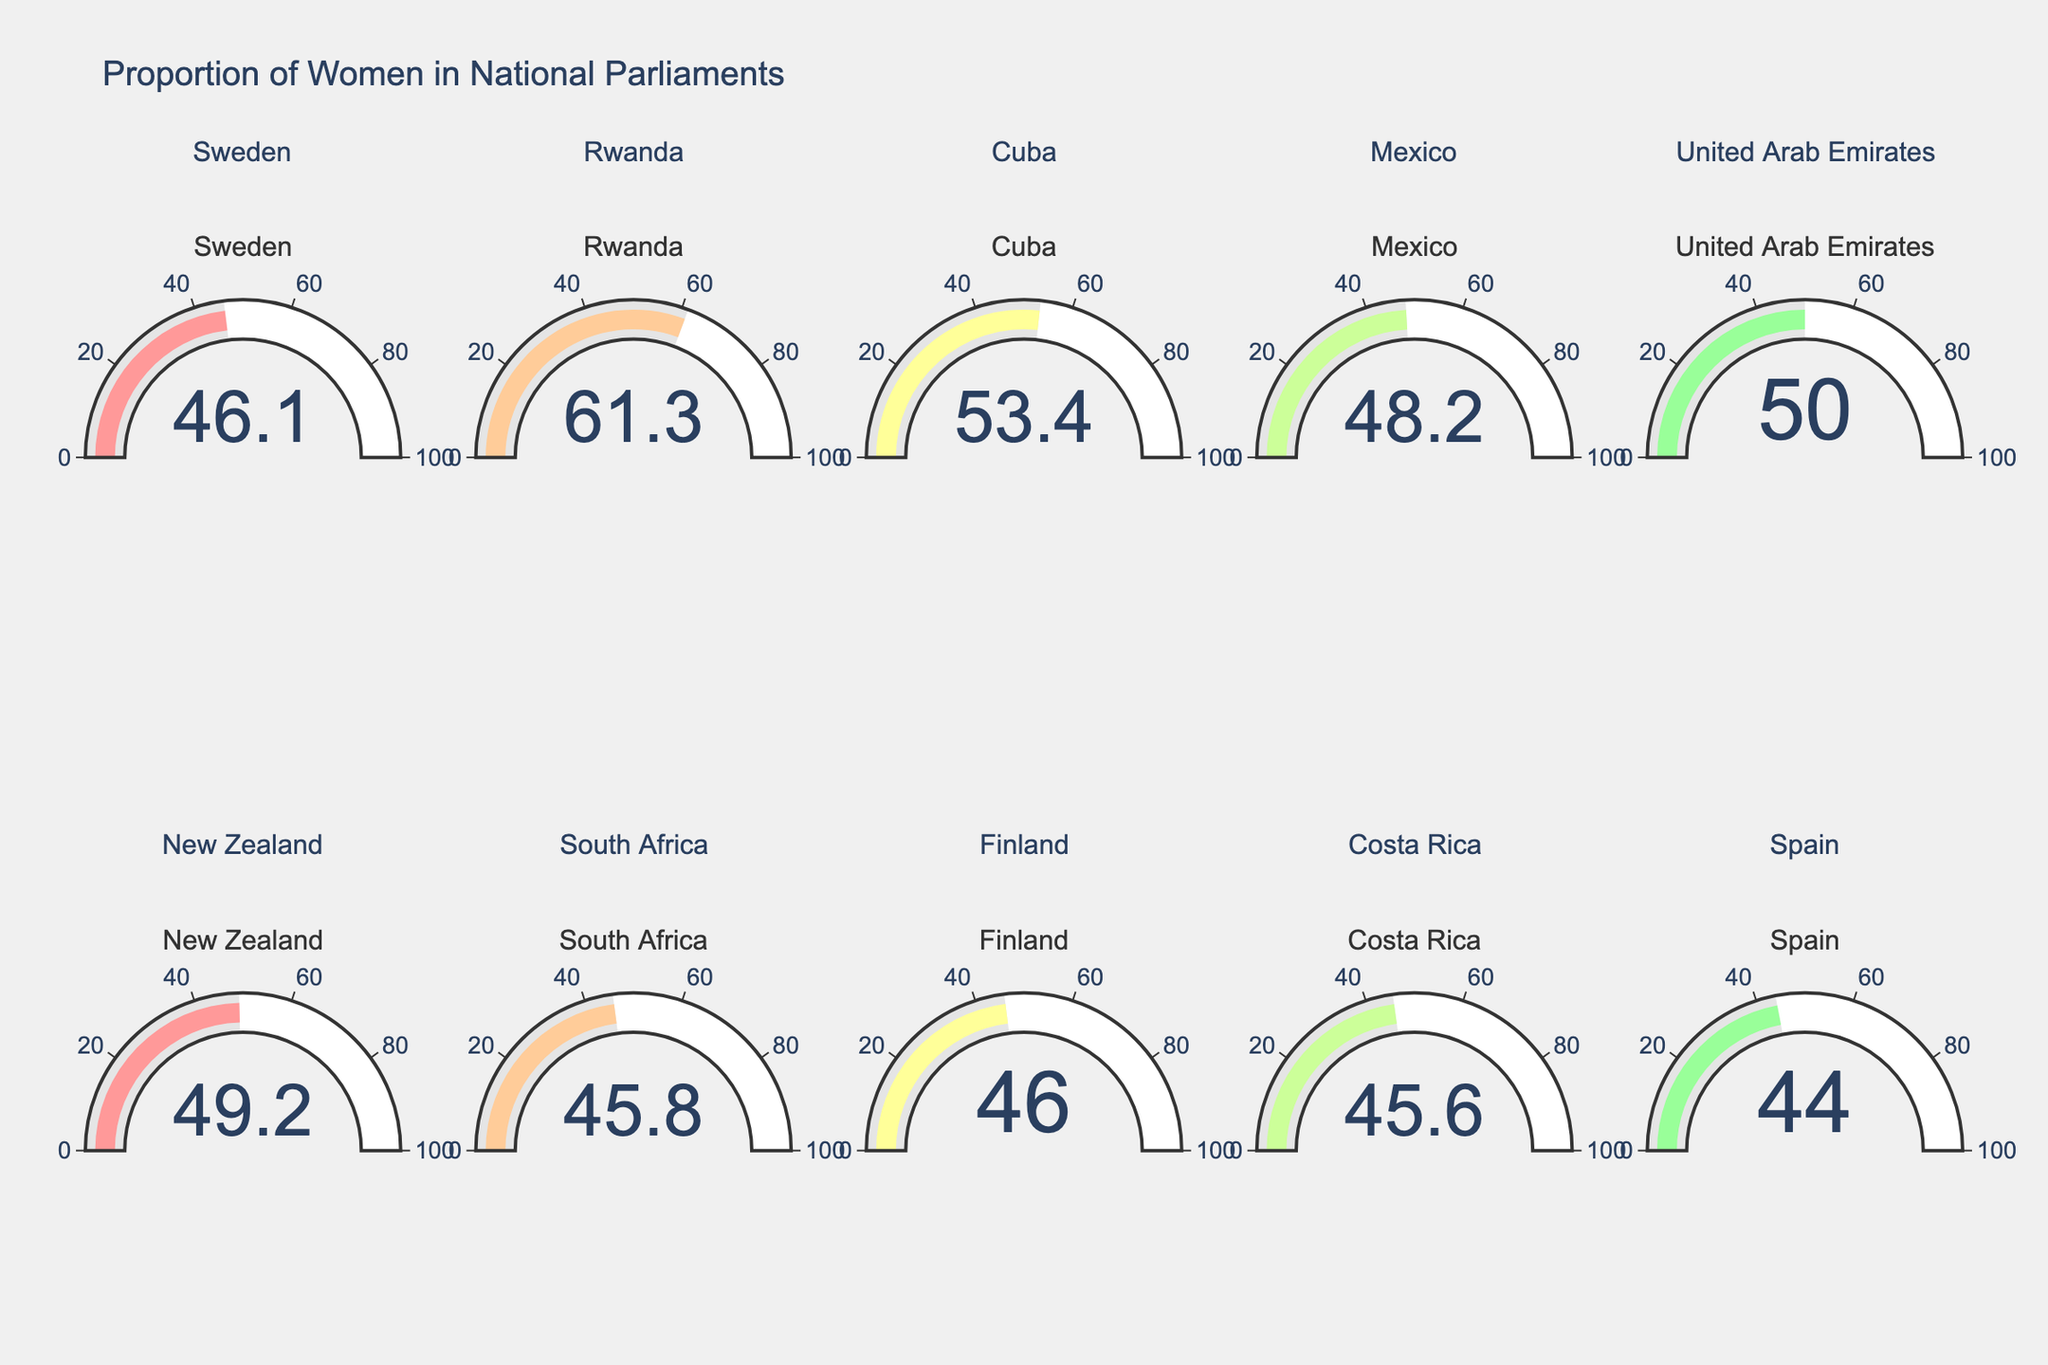What's the country with the highest proportion of women in parliament? The country with the highest value on the gauge is looked at; Rwanda has the highest proportion at 61.3%.
Answer: Rwanda What is the average proportion of women in national parliaments across all displayed countries? Add all the percentages and divide by the number of countries: (46.1 + 61.3 + 53.4 + 48.2 + 50.0 + 49.2 + 45.8 + 46.0 + 45.6 + 44.0) / 10 = 489.6 / 10 = 48.96.
Answer: 48.96% How many countries have a proportion of women in parliament above 50%? Count the gauges with values above 50: Rwanda, Cuba, Mexico, United Arab Emirates. There are 4 such countries.
Answer: 4 Which country has a slightly higher proportion of women in parliament, Finland or Sweden? Compare the values for Finland (46.0%) and Sweden (46.1%), and see Sweden's gauge is slightly higher.
Answer: Sweden What is the difference in the proportion of women in parliament between the country with the highest and the country with the lowest proportion? Subtract the lowest percentage (Spain, 44.0%) from the highest percentage (Rwanda, 61.3%): 61.3 - 44.0 = 17.3.
Answer: 17.3% Which countries have a proportion of women in parliament close to 45%? Check the gauges around 45%. These countries are South Africa (45.8%), Finland (46.0%), and Costa Rica (45.6%).
Answer: South Africa, Finland, Costa Rica What's the median proportion of women in parliaments in the figure? Arrange the values: 44.0, 45.6, 45.8, 46.0, 46.1, 48.2, 49.2, 50.0, 53.4, 61.3. The middle value (5th and 6th) is (46.1 + 48.2) / 2 = 47.15.
Answer: 47.15% If the number of countries with women representation between 45% and 50% increased by 2, what would the new count be? Currently counting the countries (Sweden, Mexico, New Zealand, South Africa, Finland, Costa Rica) gives 6. Adding 2, we get 8.
Answer: 8 Which country is immediately less represented than the United Arab Emirates in the plot? Identify the gauge just below the Emirates' 50.0%, which is New Zealand with 49.2%.
Answer: New Zealand 